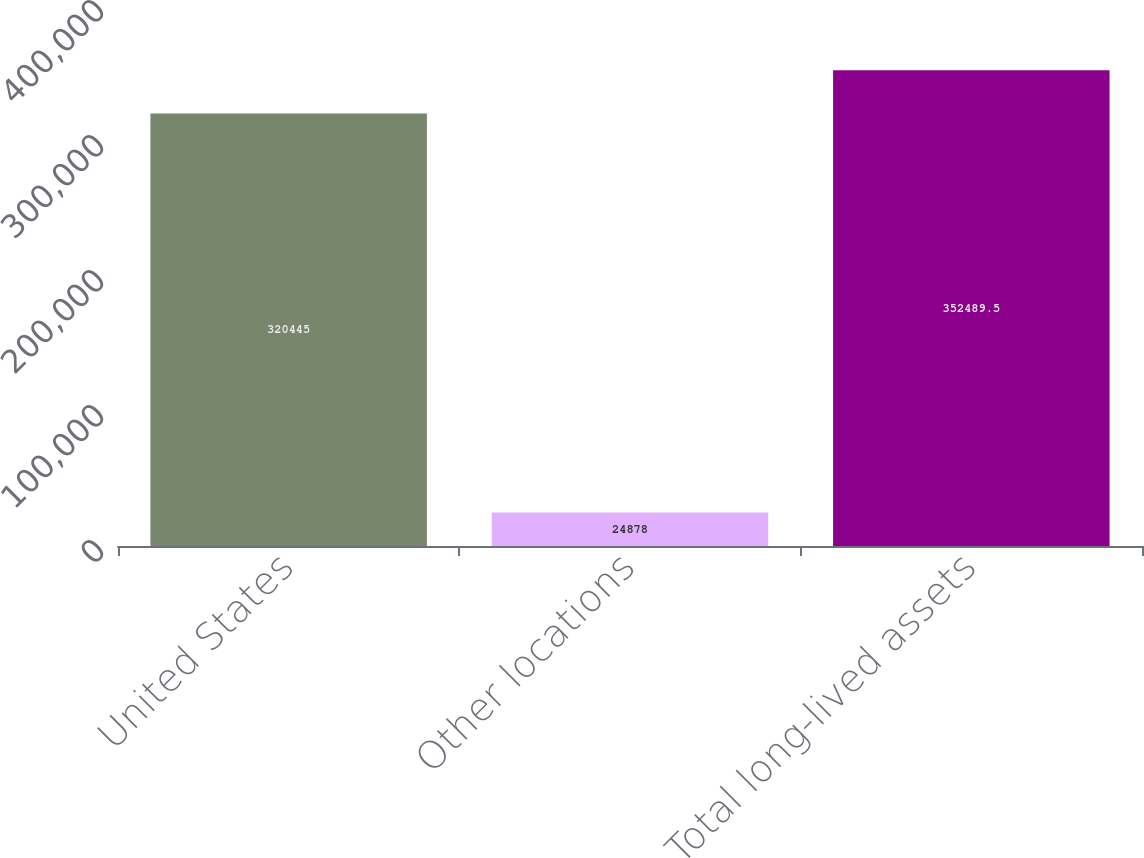<chart> <loc_0><loc_0><loc_500><loc_500><bar_chart><fcel>United States<fcel>Other locations<fcel>Total long-lived assets<nl><fcel>320445<fcel>24878<fcel>352490<nl></chart> 